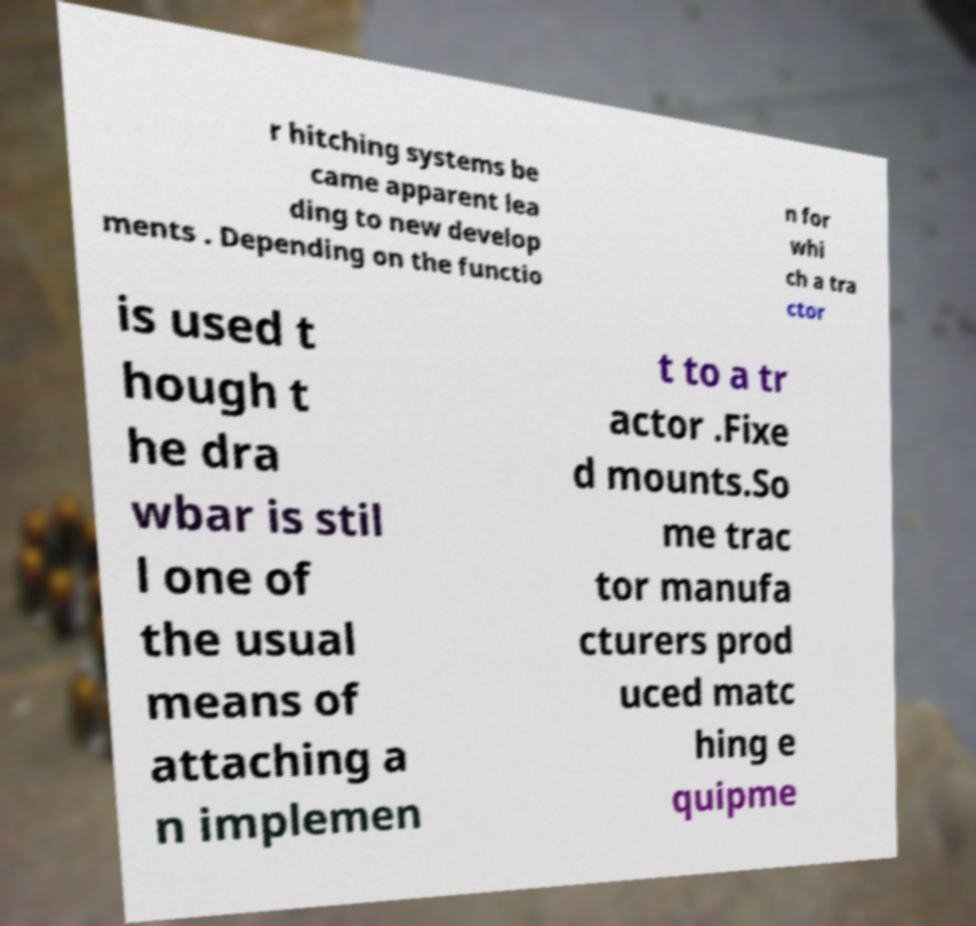Could you assist in decoding the text presented in this image and type it out clearly? r hitching systems be came apparent lea ding to new develop ments . Depending on the functio n for whi ch a tra ctor is used t hough t he dra wbar is stil l one of the usual means of attaching a n implemen t to a tr actor .Fixe d mounts.So me trac tor manufa cturers prod uced matc hing e quipme 